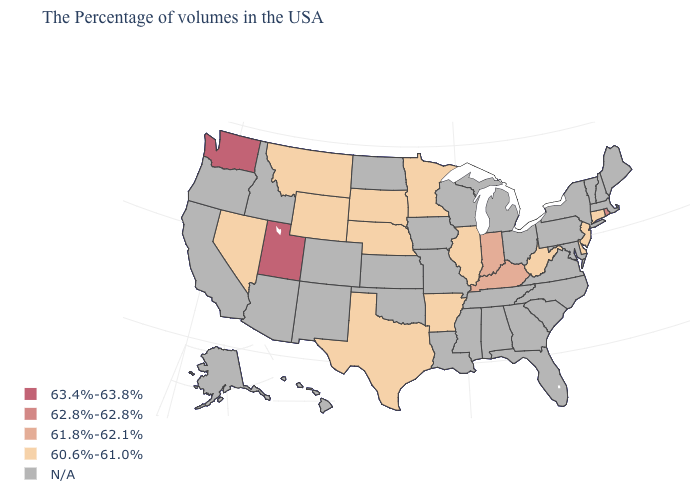Does the map have missing data?
Write a very short answer. Yes. What is the lowest value in the USA?
Quick response, please. 60.6%-61.0%. Name the states that have a value in the range 60.6%-61.0%?
Keep it brief. Connecticut, New Jersey, Delaware, West Virginia, Illinois, Arkansas, Minnesota, Nebraska, Texas, South Dakota, Wyoming, Montana, Nevada. Which states have the highest value in the USA?
Write a very short answer. Utah, Washington. What is the value of West Virginia?
Give a very brief answer. 60.6%-61.0%. Name the states that have a value in the range N/A?
Short answer required. Maine, Massachusetts, New Hampshire, Vermont, New York, Maryland, Pennsylvania, Virginia, North Carolina, South Carolina, Ohio, Florida, Georgia, Michigan, Alabama, Tennessee, Wisconsin, Mississippi, Louisiana, Missouri, Iowa, Kansas, Oklahoma, North Dakota, Colorado, New Mexico, Arizona, Idaho, California, Oregon, Alaska, Hawaii. What is the lowest value in states that border Idaho?
Answer briefly. 60.6%-61.0%. Does Washington have the lowest value in the USA?
Give a very brief answer. No. What is the value of California?
Give a very brief answer. N/A. Name the states that have a value in the range 61.8%-62.1%?
Write a very short answer. Kentucky, Indiana. Which states hav the highest value in the Northeast?
Be succinct. Rhode Island. Which states hav the highest value in the West?
Short answer required. Utah, Washington. What is the highest value in the USA?
Write a very short answer. 63.4%-63.8%. Name the states that have a value in the range N/A?
Quick response, please. Maine, Massachusetts, New Hampshire, Vermont, New York, Maryland, Pennsylvania, Virginia, North Carolina, South Carolina, Ohio, Florida, Georgia, Michigan, Alabama, Tennessee, Wisconsin, Mississippi, Louisiana, Missouri, Iowa, Kansas, Oklahoma, North Dakota, Colorado, New Mexico, Arizona, Idaho, California, Oregon, Alaska, Hawaii. 